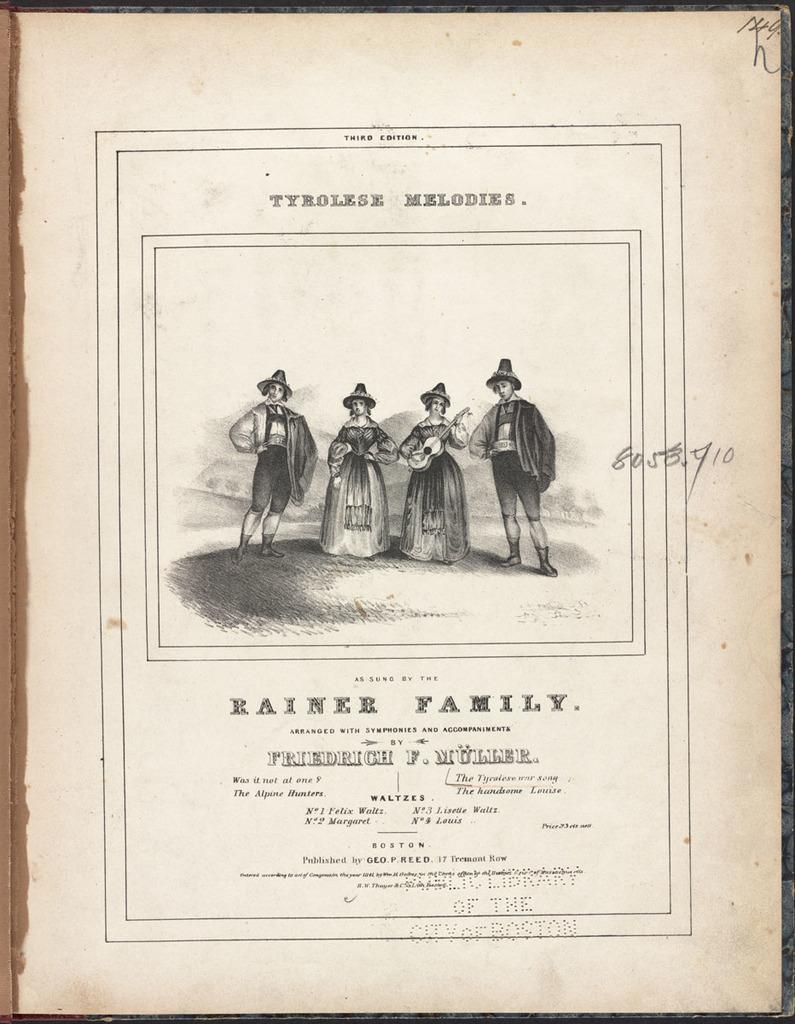What is depicted in the drawings in the image? There are drawings of a person in the image. Where is the person in the drawings located? The person is standing on the grass. What is written at the top of the image? There is text at the top of the image. What is written at the bottom of the image? There is text at the bottom of the image. How many rings are being worn by the person in the image? There are no rings visible in the image, as it only features drawings of a person standing on the grass with text at the top and bottom. 